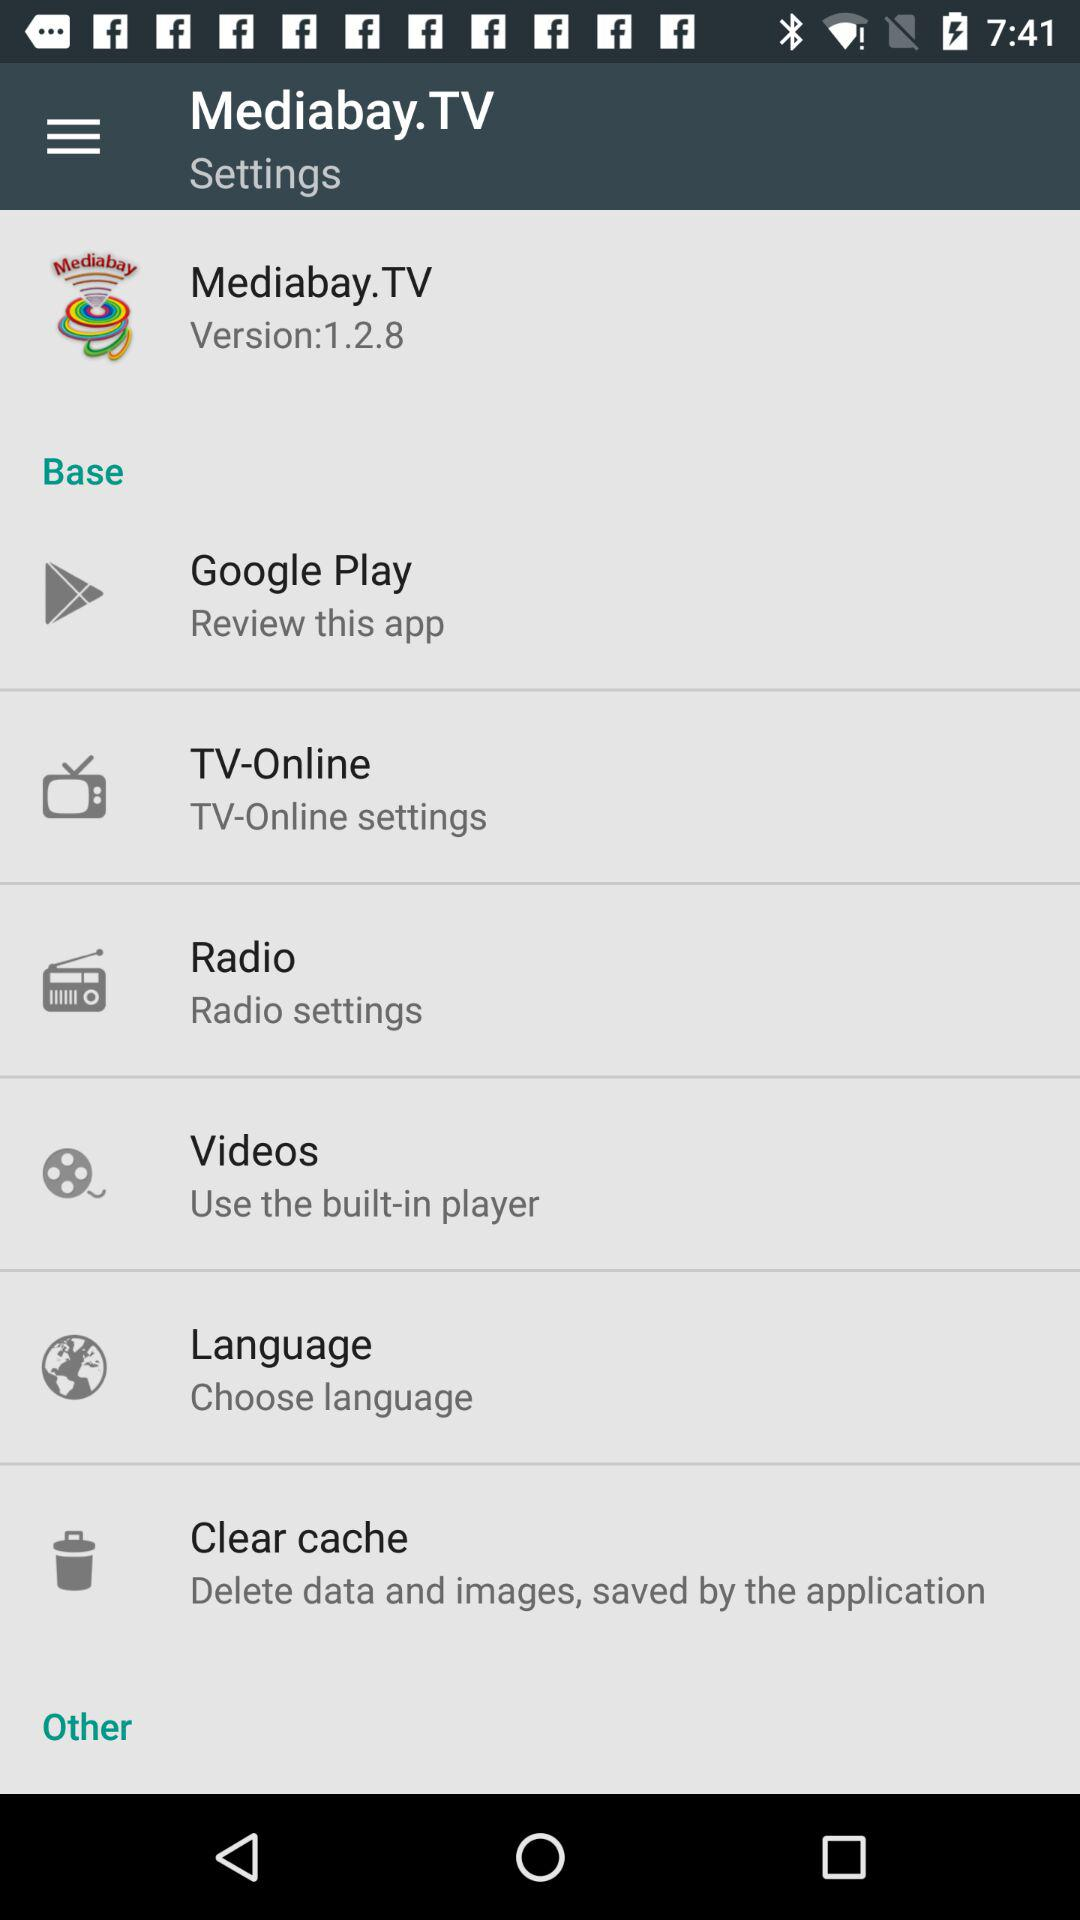What is the version of Mediabay.TV? The version is 1.2.8. 